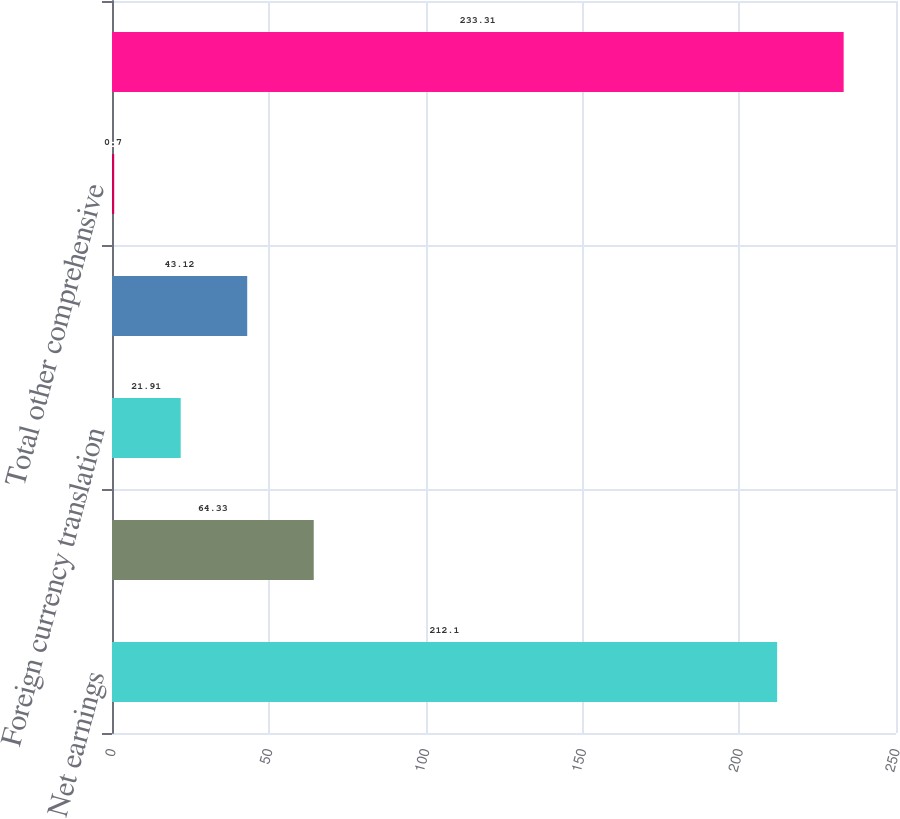<chart> <loc_0><loc_0><loc_500><loc_500><bar_chart><fcel>Net earnings<fcel>Other comprehensive income<fcel>Foreign currency translation<fcel>income net of taxes of (40)<fcel>Total other comprehensive<fcel>Comprehensive income<nl><fcel>212.1<fcel>64.33<fcel>21.91<fcel>43.12<fcel>0.7<fcel>233.31<nl></chart> 